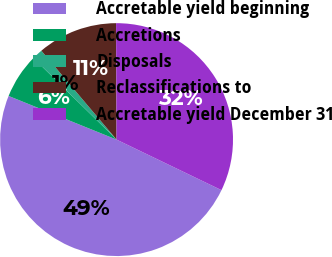Convert chart to OTSL. <chart><loc_0><loc_0><loc_500><loc_500><pie_chart><fcel>Accretable yield beginning<fcel>Accretions<fcel>Disposals<fcel>Reclassifications to<fcel>Accretable yield December 31<nl><fcel>48.98%<fcel>6.23%<fcel>1.48%<fcel>11.11%<fcel>32.22%<nl></chart> 